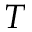Convert formula to latex. <formula><loc_0><loc_0><loc_500><loc_500>T</formula> 